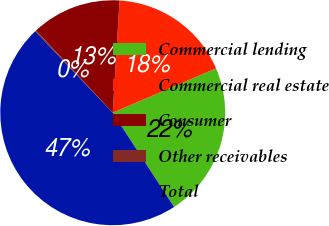Convert chart. <chart><loc_0><loc_0><loc_500><loc_500><pie_chart><fcel>Commercial lending<fcel>Commercial real estate<fcel>Consumer<fcel>Other receivables<fcel>Total<nl><fcel>22.27%<fcel>17.58%<fcel>12.9%<fcel>0.19%<fcel>47.06%<nl></chart> 